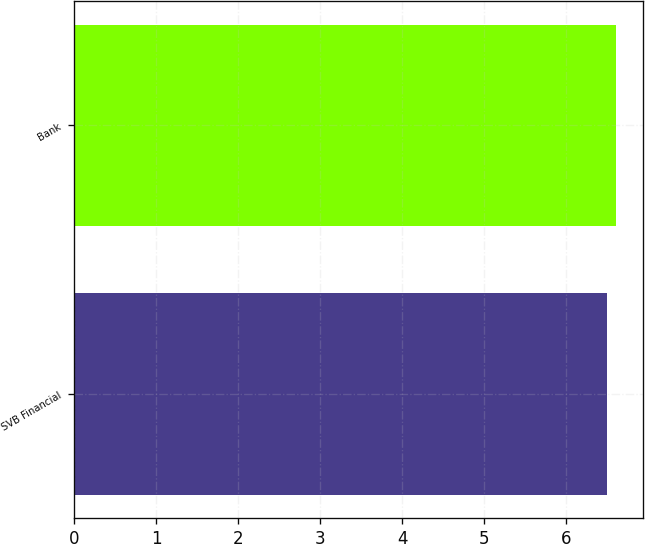Convert chart. <chart><loc_0><loc_0><loc_500><loc_500><bar_chart><fcel>SVB Financial<fcel>Bank<nl><fcel>6.5<fcel>6.6<nl></chart> 